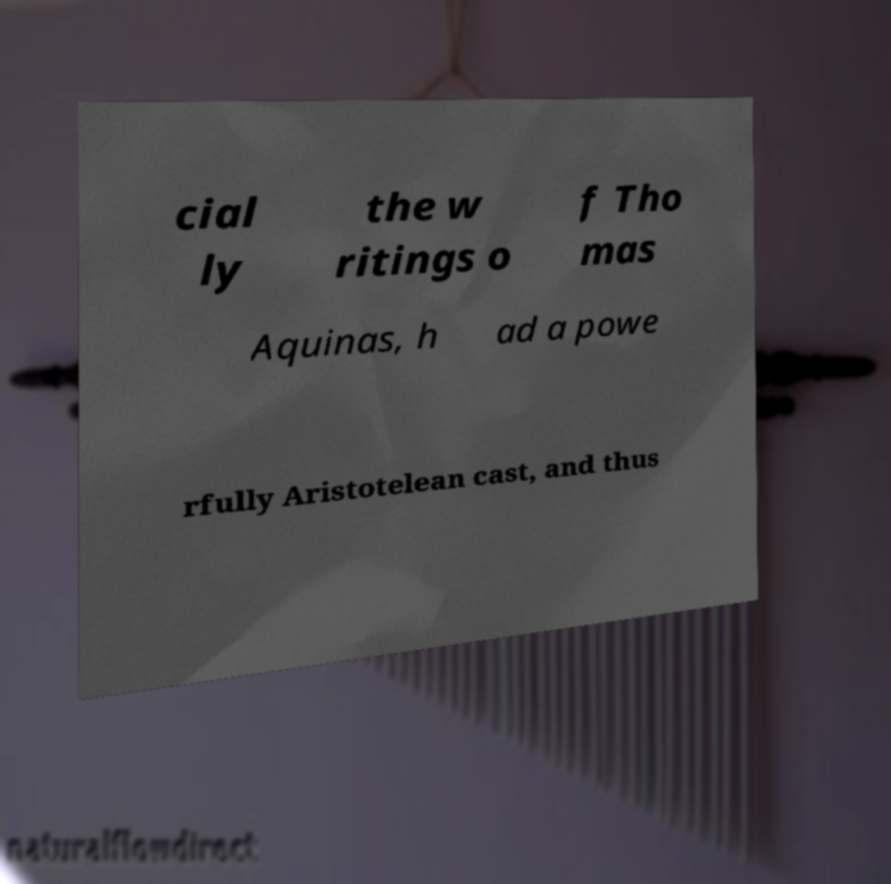Please read and relay the text visible in this image. What does it say? cial ly the w ritings o f Tho mas Aquinas, h ad a powe rfully Aristotelean cast, and thus 